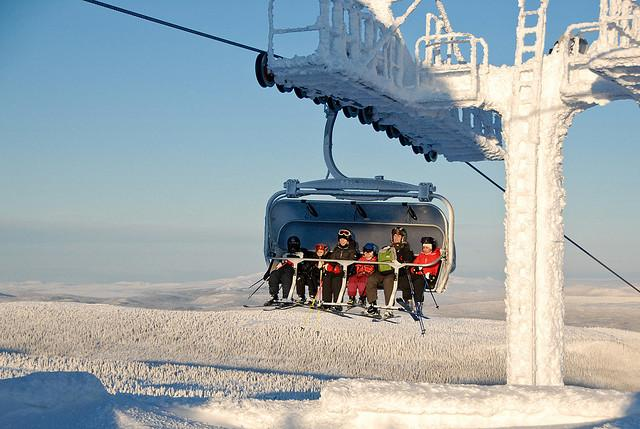Where is this group headed? up mountain 